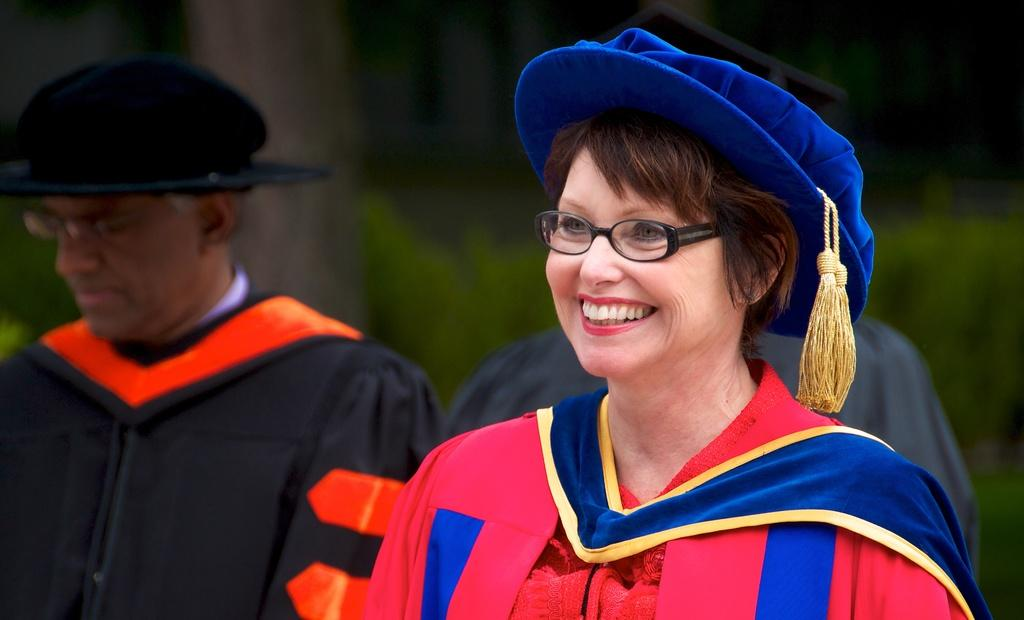What can be seen in the image? There are people standing in the image. What are the people wearing on their heads? The people are wearing hats. What can be seen in the background of the image? There are plants in the background of the image. How many ants can be seen crawling on the dirt in the image? There are no ants or dirt present in the image. 